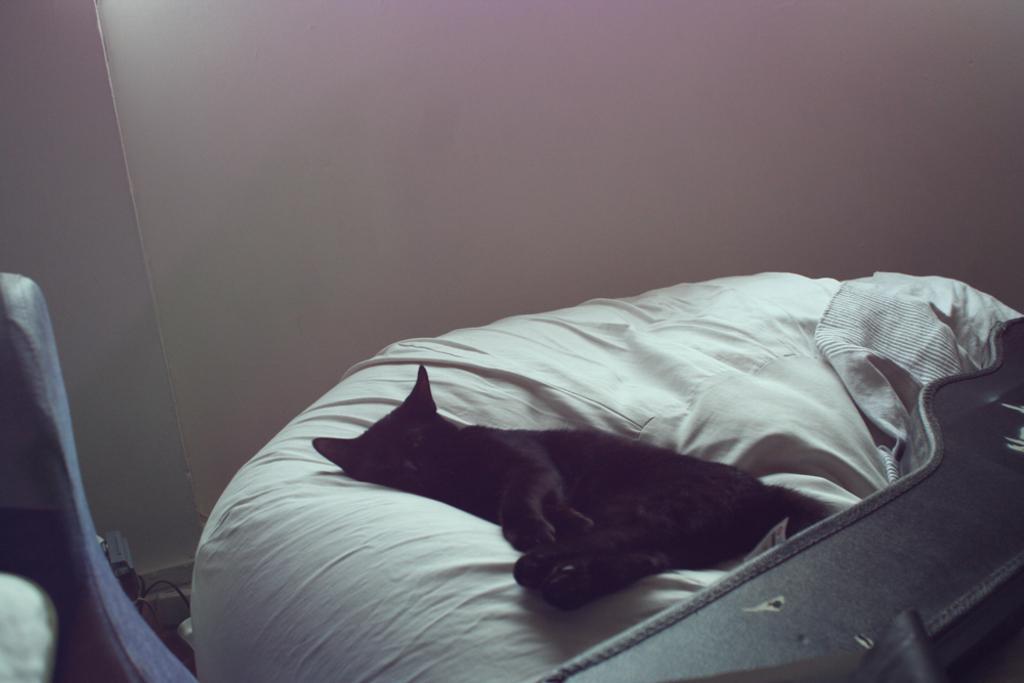Please provide a concise description of this image. In this picture we can see a cat laying on the bed. 